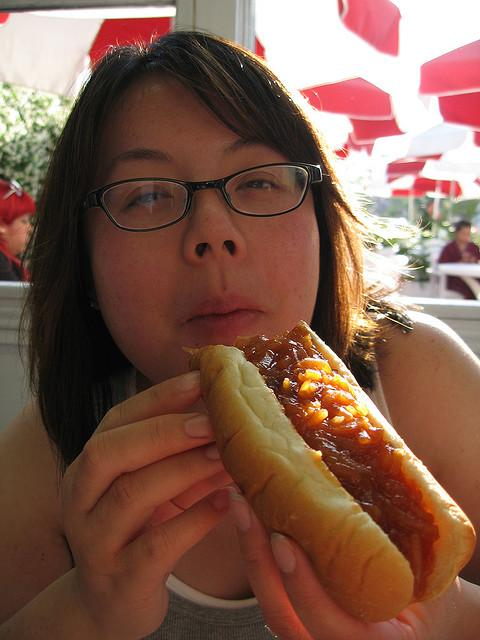In what place was the bread eaten here cooked?

Choices:
A) grill
B) oven
C) deep fryer
D) fryer oven 